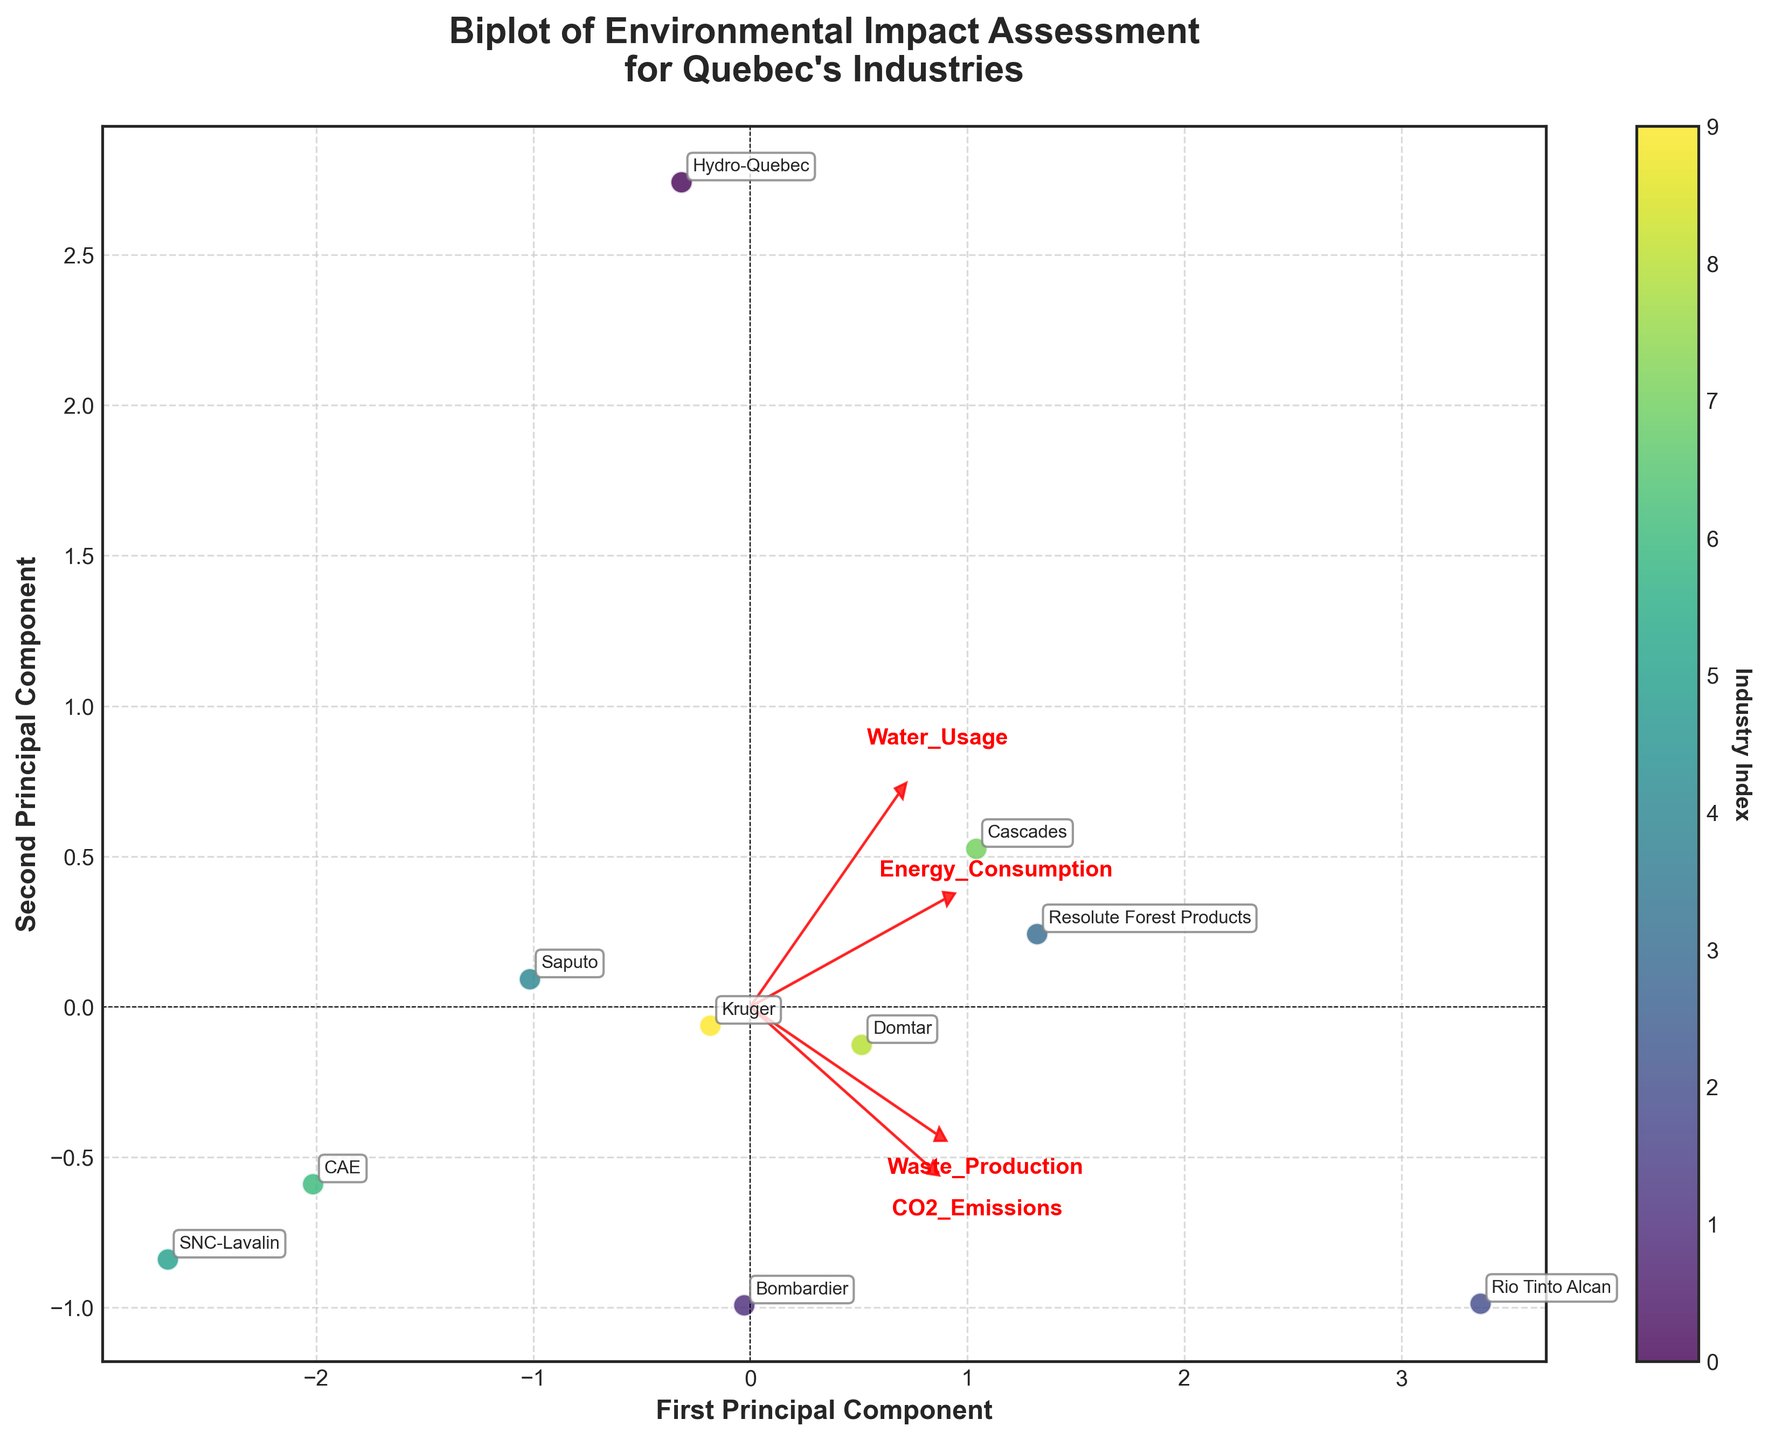What's the title of the biplot? The title is displayed at the top-center of the plot and provides context for the data being visualized.
Answer: "Biplot of Environmental Impact Assessment\nfor Quebec's Industries" How many industries are represented in the biplot? Each industry is represented by a point annotated with its name. Count the number of unique labels.
Answer: 10 Which industry has the highest CO2 emissions? Referring to the biplot, locate the axis arrow labeled 'CO2_Emissions' and find the industry farthest in the direction of this arrow.
Answer: Rio Tinto Alcan Which two industries are the closest in terms of their principal component scores? Examine the biplot and identify the pairs of points that are closest to each other in the PCA space.
Answer: CAE and SNC-Lavalin How are CO2 emissions and Water Usage related to the first principal component? Look at the direction and length of the arrows for 'CO2_Emissions' and 'Water_Usage'. The first principal component is aligned with these arrows.
Answer: Both are positively related to the first principal component Which industry has the lowest Water Usage? Identify the industry closest to the opposite direction of the 'Water_Usage' arrow.
Answer: SNC-Lavalin Which industry has the highest Energy Consumption and Waste Production? Referring to the arrows labeled 'Energy_Consumption' and 'Waste_Production', and finding the industry farthest in these directions.
Answer: Rio Tinto Alcan What can be inferred about Hydro-Quebec's overall environmental impact compared to other industries? Hydro-Quebec is positioned relatively low on both principal components, indicating lower scores on the environmental measures compared to others.
Answer: Hydro-Quebec has a relatively low environmental impact How are Energy Consumption and Waste Production related? Observing the vectors for 'Energy_Consumption' and 'Waste_Production', if they point in similar directions, it suggests a positive correlation.
Answer: Positively related 